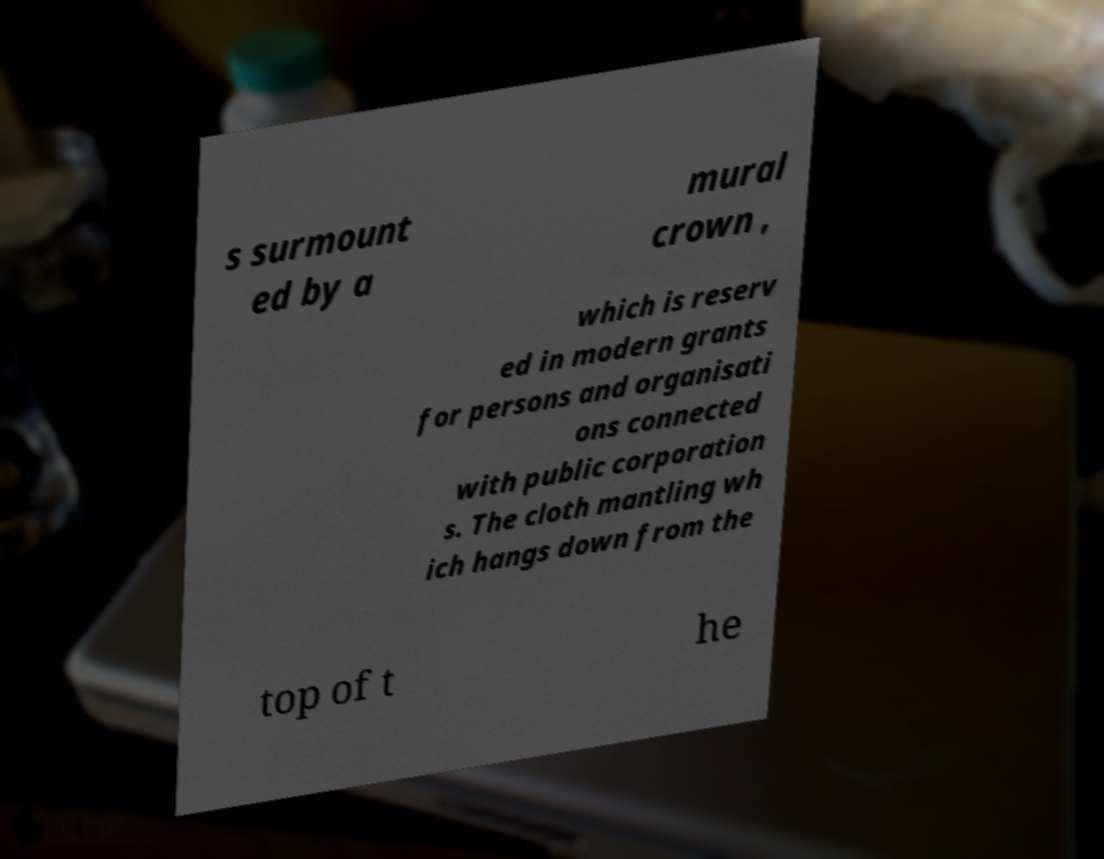Can you read and provide the text displayed in the image?This photo seems to have some interesting text. Can you extract and type it out for me? s surmount ed by a mural crown , which is reserv ed in modern grants for persons and organisati ons connected with public corporation s. The cloth mantling wh ich hangs down from the top of t he 